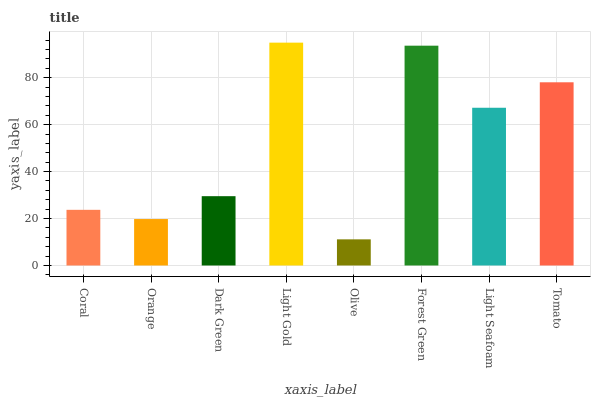Is Olive the minimum?
Answer yes or no. Yes. Is Light Gold the maximum?
Answer yes or no. Yes. Is Orange the minimum?
Answer yes or no. No. Is Orange the maximum?
Answer yes or no. No. Is Coral greater than Orange?
Answer yes or no. Yes. Is Orange less than Coral?
Answer yes or no. Yes. Is Orange greater than Coral?
Answer yes or no. No. Is Coral less than Orange?
Answer yes or no. No. Is Light Seafoam the high median?
Answer yes or no. Yes. Is Dark Green the low median?
Answer yes or no. Yes. Is Light Gold the high median?
Answer yes or no. No. Is Olive the low median?
Answer yes or no. No. 